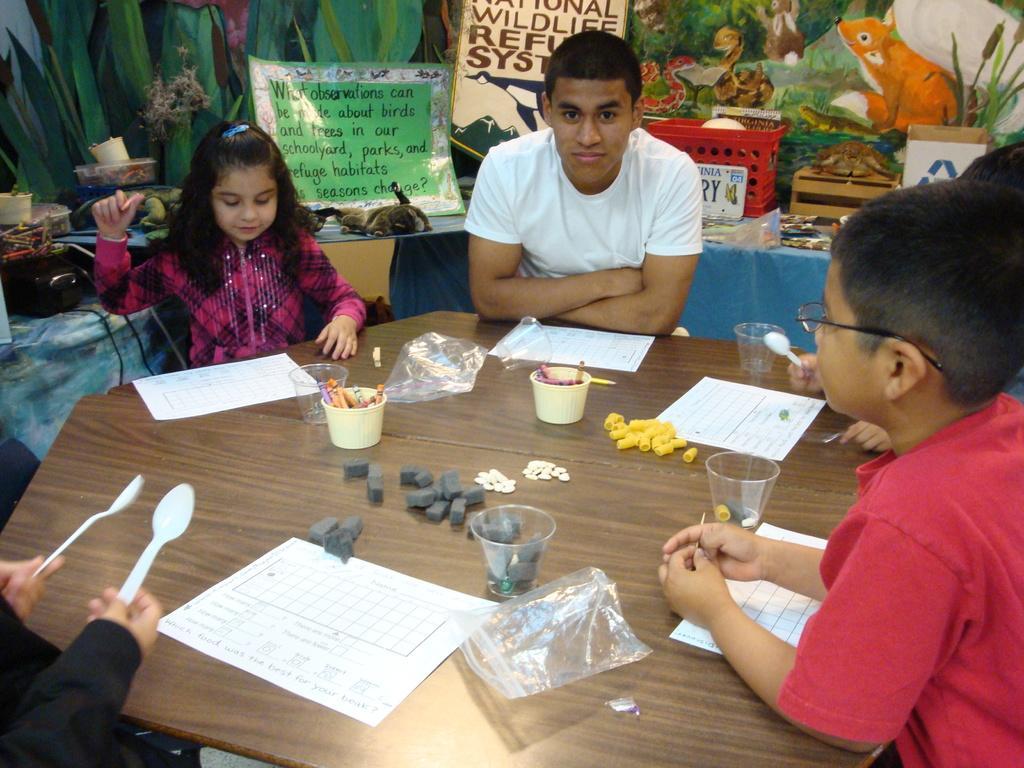Please provide a concise description of this image. There is a table at here the people are sitting around table there are papers,spoons. Here is a girl. she is wearing a pink color dress. here boy is wearing a white color T-shirt. 